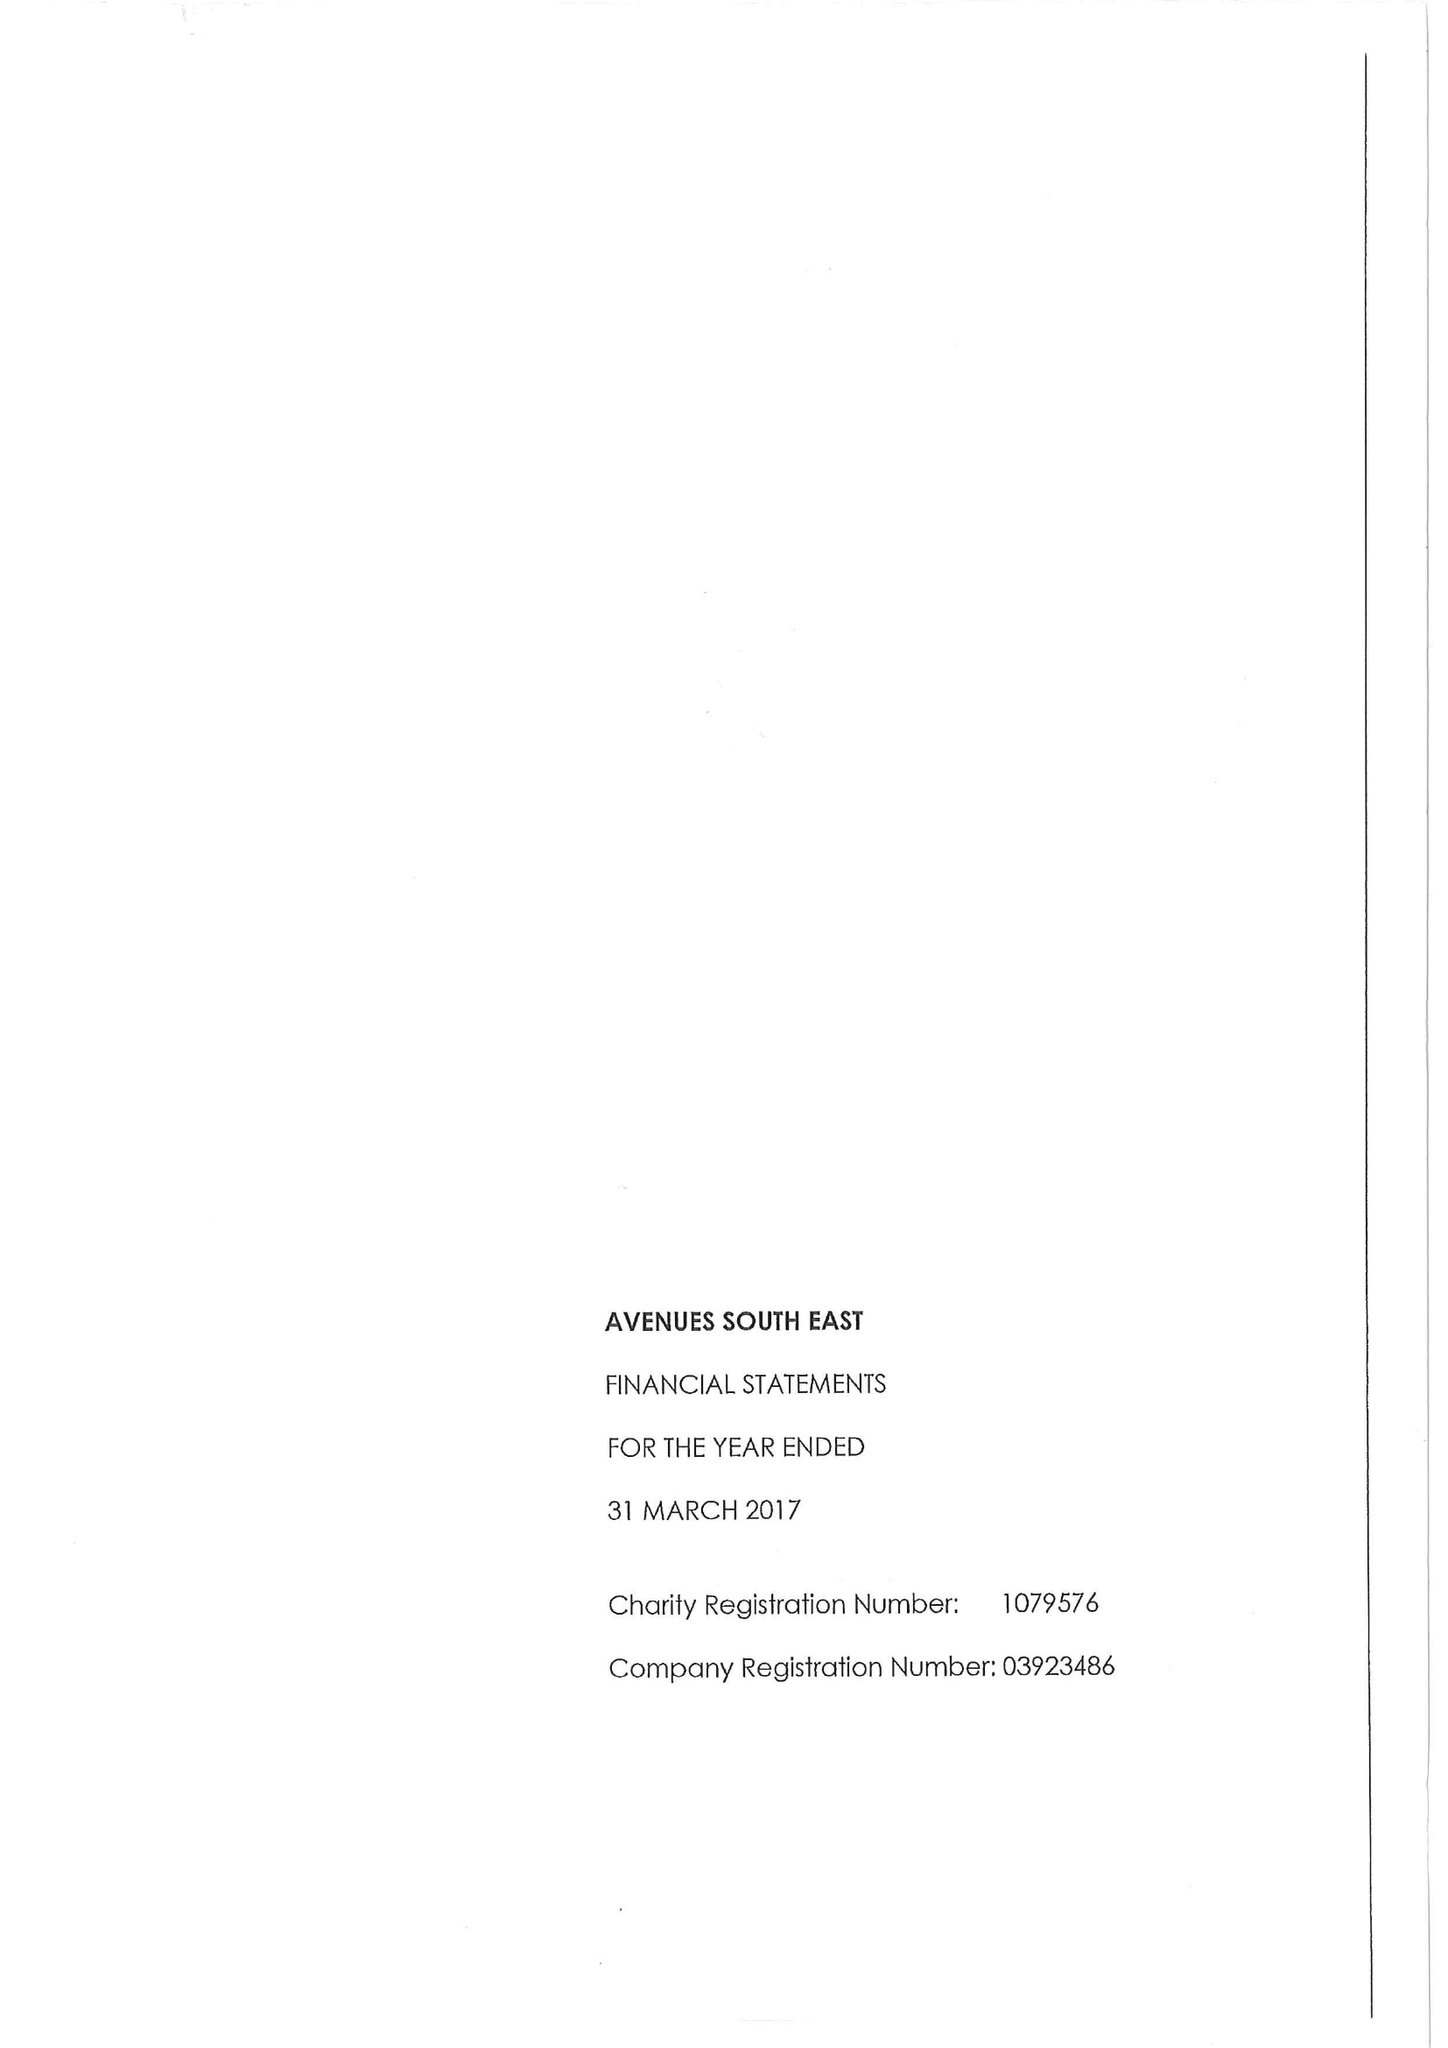What is the value for the report_date?
Answer the question using a single word or phrase. 2017-03-31 